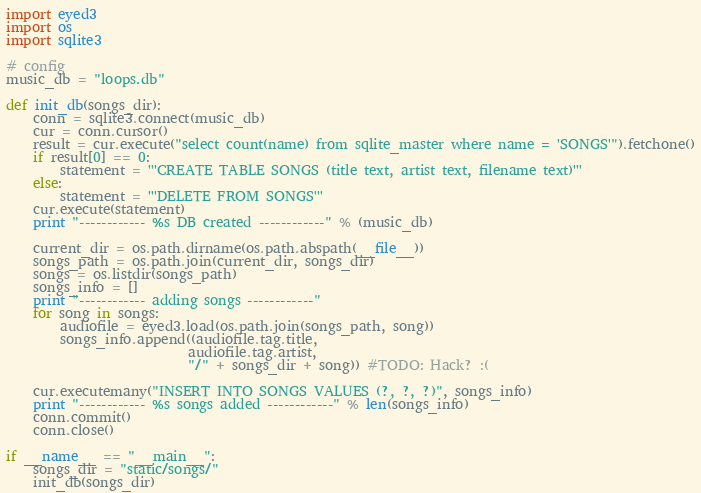Convert code to text. <code><loc_0><loc_0><loc_500><loc_500><_Python_>import eyed3
import os
import sqlite3

# config
music_db = "loops.db"

def init_db(songs_dir):
    conn = sqlite3.connect(music_db)
    cur = conn.cursor()
    result = cur.execute("select count(name) from sqlite_master where name = 'SONGS'").fetchone()
    if result[0] == 0:
        statement = '''CREATE TABLE SONGS (title text, artist text, filename text)'''
    else:
        statement = '''DELETE FROM SONGS'''
    cur.execute(statement)
    print "------------ %s DB created ------------" % (music_db)

    current_dir = os.path.dirname(os.path.abspath(__file__))
    songs_path = os.path.join(current_dir, songs_dir)
    songs = os.listdir(songs_path)
    songs_info = []
    print "------------ adding songs ------------"
    for song in songs:
        audiofile = eyed3.load(os.path.join(songs_path, song))
        songs_info.append((audiofile.tag.title,
                           audiofile.tag.artist,
                           "/" + songs_dir + song)) #TODO: Hack? :(

    cur.executemany("INSERT INTO SONGS VALUES (?, ?, ?)", songs_info)
    print "------------ %s songs added ------------" % len(songs_info)
    conn.commit()
    conn.close()

if __name__ == "__main__":
    songs_dir = "static/songs/"
    init_db(songs_dir)
</code> 